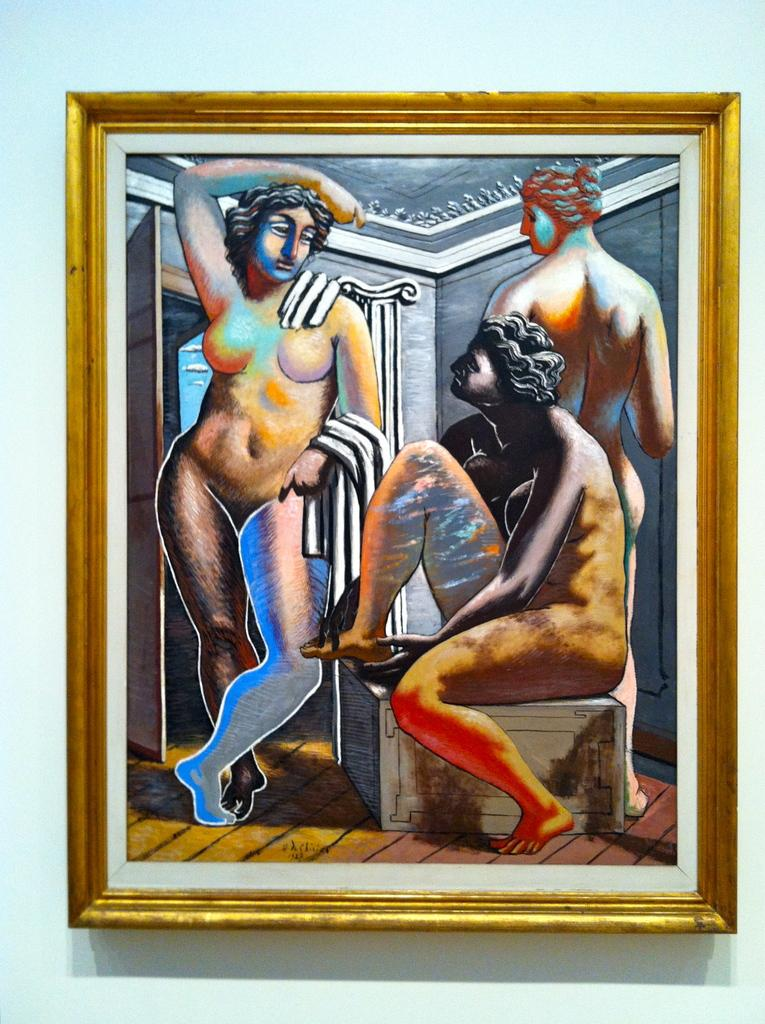What object is present in the image that typically holds photographs? There is a photo frame in the image. How many women are depicted in the photo frame? The photo frame contains images of three women. Where is the photo frame located in the image? The photo frame is placed on a white wall. Can you see a window in the image? There is no window present in the image; it only features a photo frame on a white wall. 